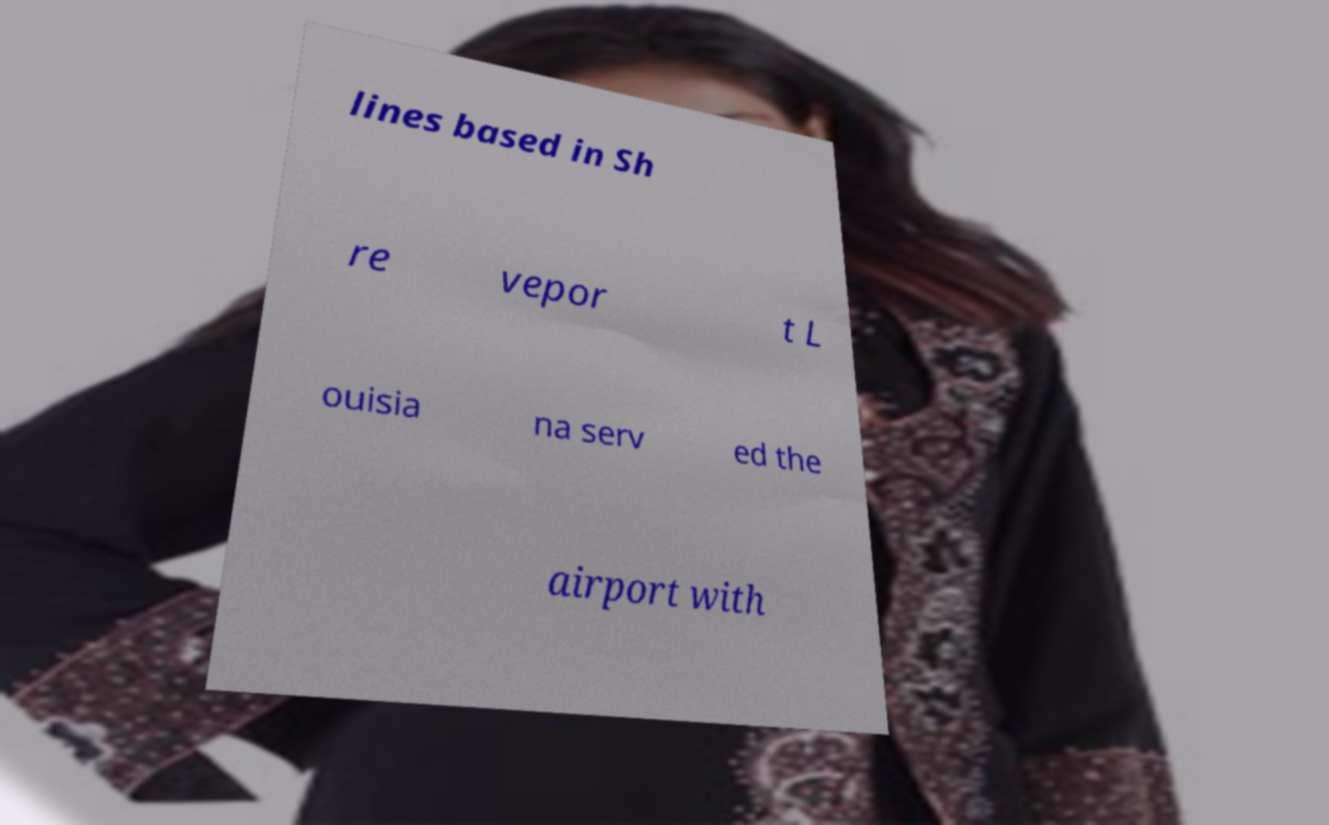What messages or text are displayed in this image? I need them in a readable, typed format. lines based in Sh re vepor t L ouisia na serv ed the airport with 